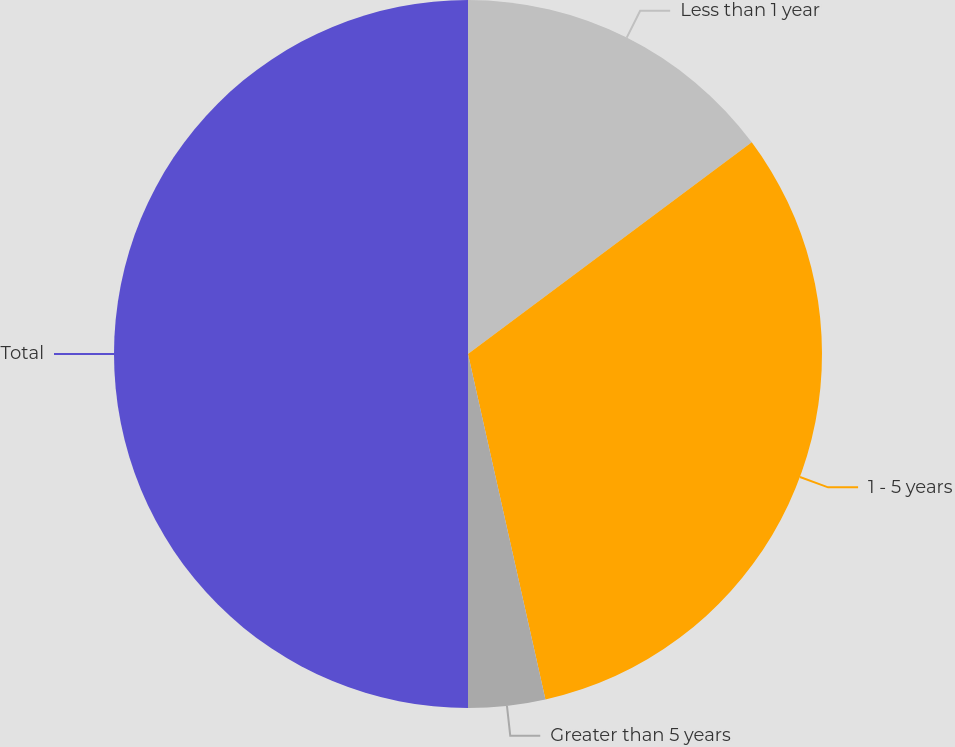Convert chart to OTSL. <chart><loc_0><loc_0><loc_500><loc_500><pie_chart><fcel>Less than 1 year<fcel>1 - 5 years<fcel>Greater than 5 years<fcel>Total<nl><fcel>14.8%<fcel>31.69%<fcel>3.51%<fcel>50.0%<nl></chart> 